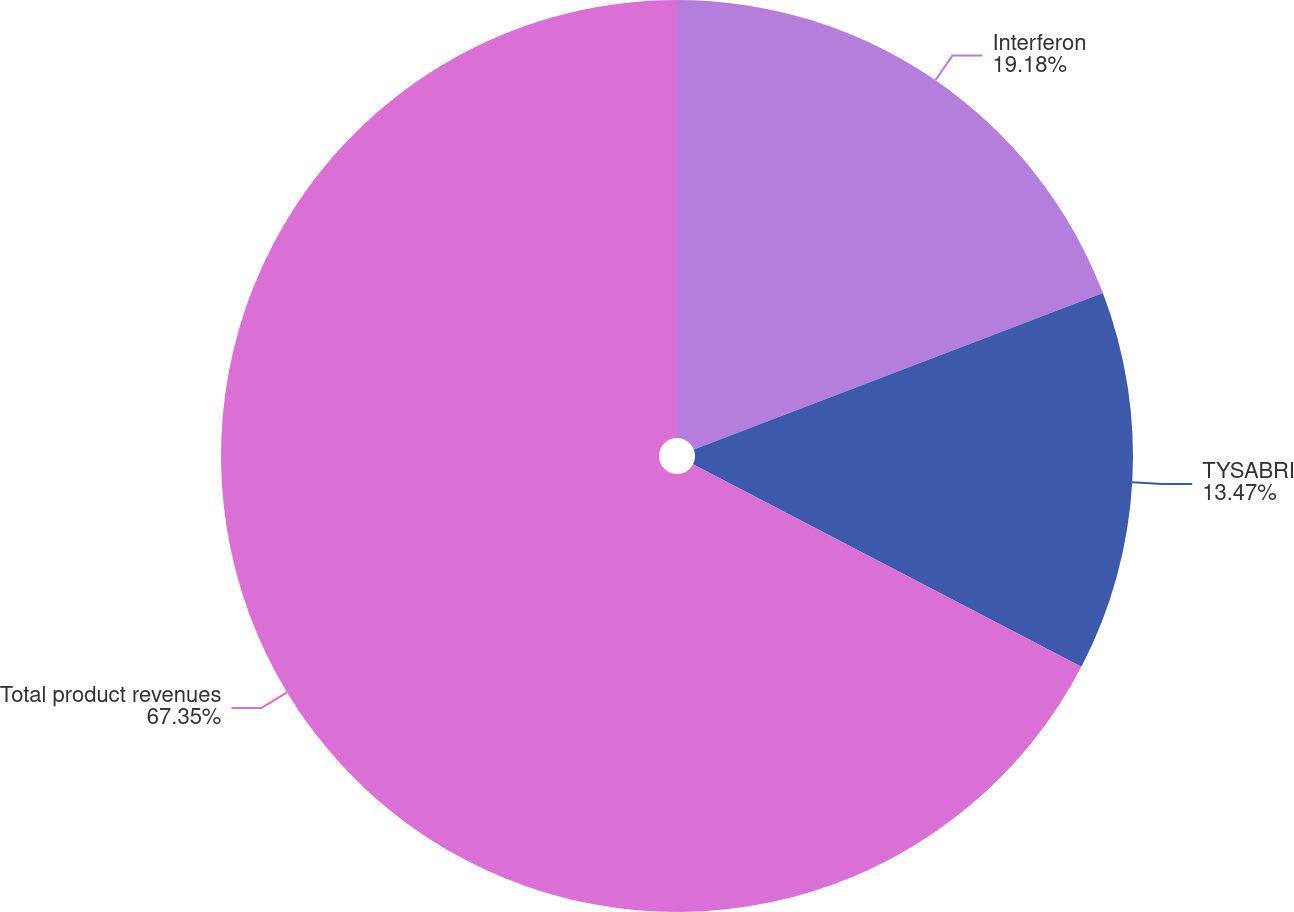Convert chart to OTSL. <chart><loc_0><loc_0><loc_500><loc_500><pie_chart><fcel>Interferon<fcel>TYSABRI<fcel>Total product revenues<nl><fcel>19.18%<fcel>13.47%<fcel>67.35%<nl></chart> 